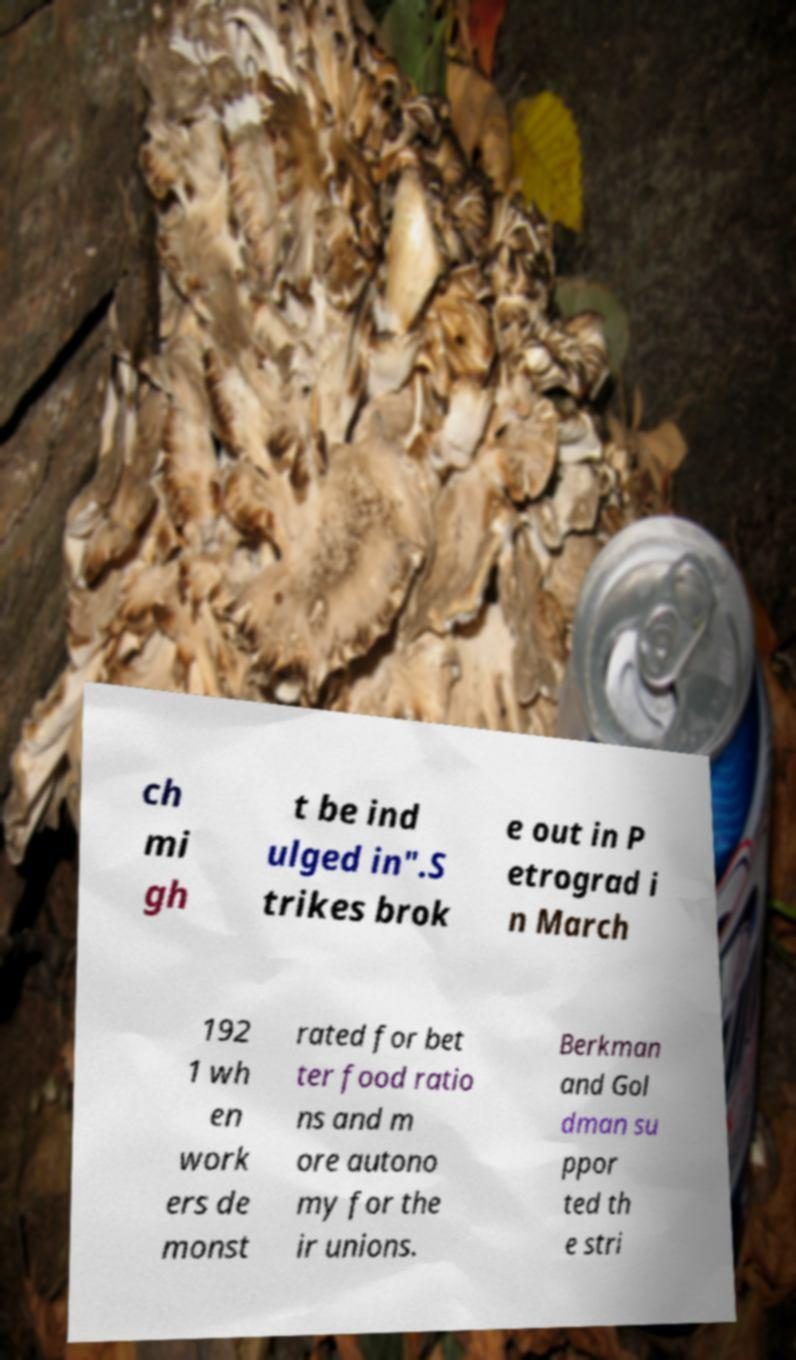For documentation purposes, I need the text within this image transcribed. Could you provide that? ch mi gh t be ind ulged in".S trikes brok e out in P etrograd i n March 192 1 wh en work ers de monst rated for bet ter food ratio ns and m ore autono my for the ir unions. Berkman and Gol dman su ppor ted th e stri 